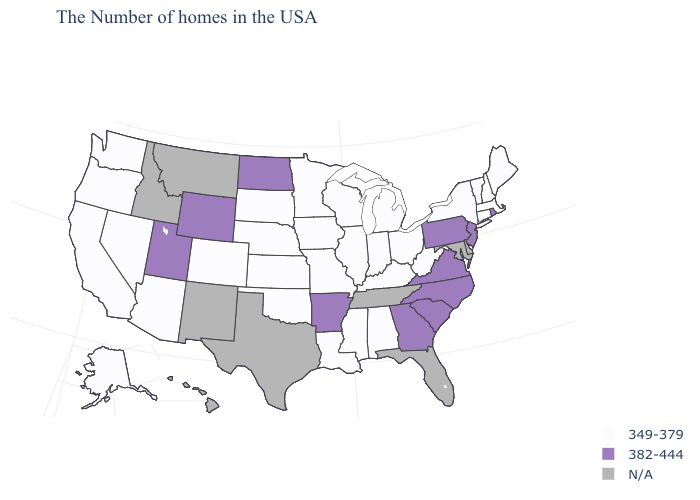What is the value of Kentucky?
Keep it brief. 349-379. How many symbols are there in the legend?
Quick response, please. 3. Does South Carolina have the highest value in the USA?
Be succinct. Yes. What is the value of Kansas?
Quick response, please. 349-379. Name the states that have a value in the range 349-379?
Concise answer only. Maine, Massachusetts, New Hampshire, Vermont, Connecticut, New York, West Virginia, Ohio, Michigan, Kentucky, Indiana, Alabama, Wisconsin, Illinois, Mississippi, Louisiana, Missouri, Minnesota, Iowa, Kansas, Nebraska, Oklahoma, South Dakota, Colorado, Arizona, Nevada, California, Washington, Oregon, Alaska. What is the value of Massachusetts?
Be succinct. 349-379. What is the value of Hawaii?
Quick response, please. N/A. Name the states that have a value in the range 349-379?
Concise answer only. Maine, Massachusetts, New Hampshire, Vermont, Connecticut, New York, West Virginia, Ohio, Michigan, Kentucky, Indiana, Alabama, Wisconsin, Illinois, Mississippi, Louisiana, Missouri, Minnesota, Iowa, Kansas, Nebraska, Oklahoma, South Dakota, Colorado, Arizona, Nevada, California, Washington, Oregon, Alaska. What is the value of Ohio?
Answer briefly. 349-379. What is the highest value in the USA?
Answer briefly. 382-444. Among the states that border Georgia , does Alabama have the lowest value?
Concise answer only. Yes. What is the value of California?
Short answer required. 349-379. Does Utah have the lowest value in the USA?
Short answer required. No. Name the states that have a value in the range 349-379?
Short answer required. Maine, Massachusetts, New Hampshire, Vermont, Connecticut, New York, West Virginia, Ohio, Michigan, Kentucky, Indiana, Alabama, Wisconsin, Illinois, Mississippi, Louisiana, Missouri, Minnesota, Iowa, Kansas, Nebraska, Oklahoma, South Dakota, Colorado, Arizona, Nevada, California, Washington, Oregon, Alaska. 